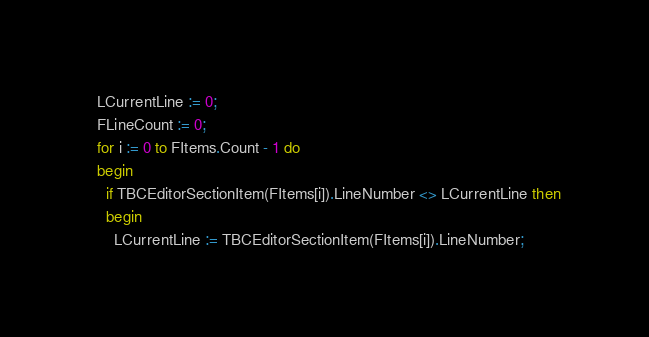Convert code to text. <code><loc_0><loc_0><loc_500><loc_500><_Pascal_>  LCurrentLine := 0;
  FLineCount := 0;
  for i := 0 to FItems.Count - 1 do
  begin
    if TBCEditorSectionItem(FItems[i]).LineNumber <> LCurrentLine then
    begin
      LCurrentLine := TBCEditorSectionItem(FItems[i]).LineNumber;</code> 